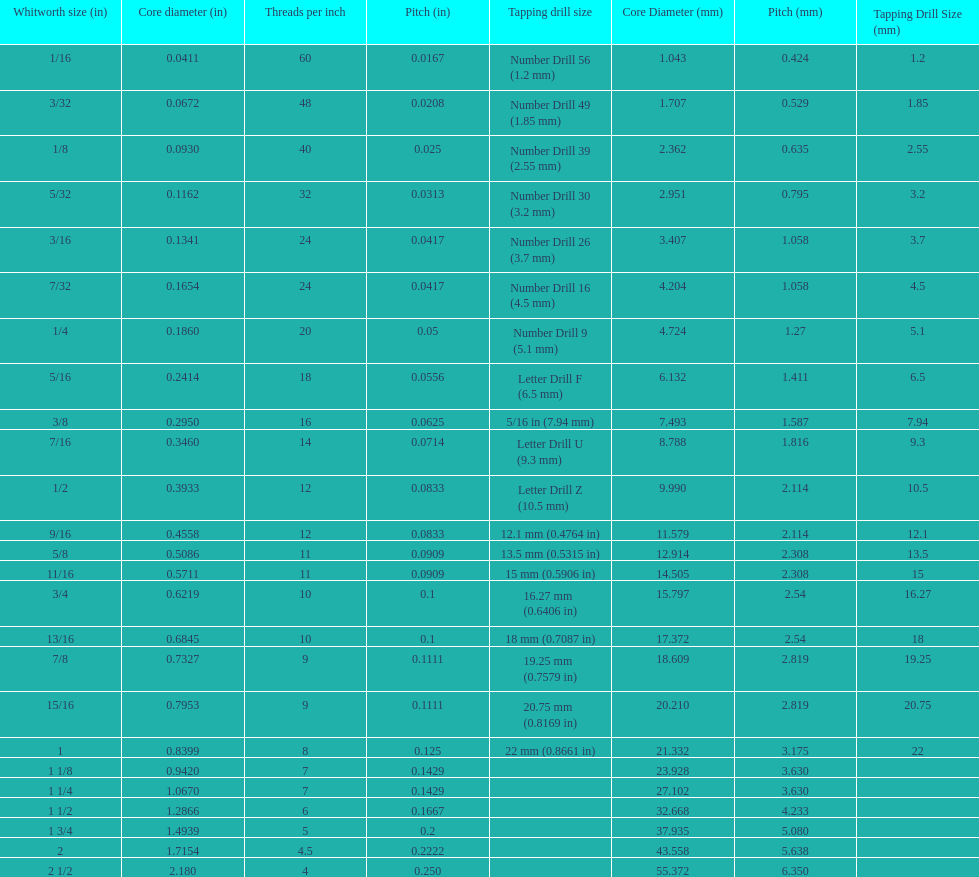How many threads per inch does a 9/16 have? 12. 